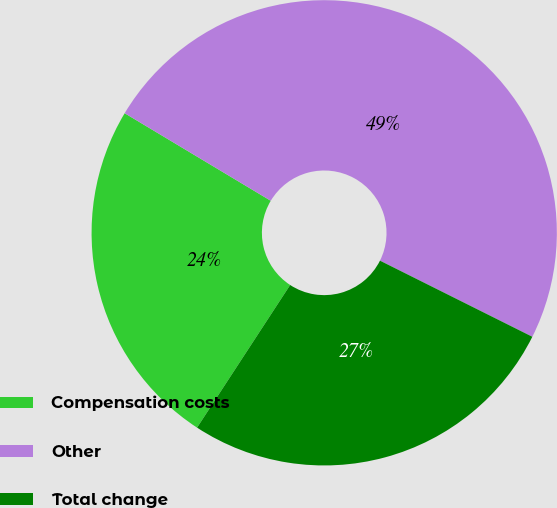<chart> <loc_0><loc_0><loc_500><loc_500><pie_chart><fcel>Compensation costs<fcel>Other<fcel>Total change<nl><fcel>24.39%<fcel>48.78%<fcel>26.83%<nl></chart> 